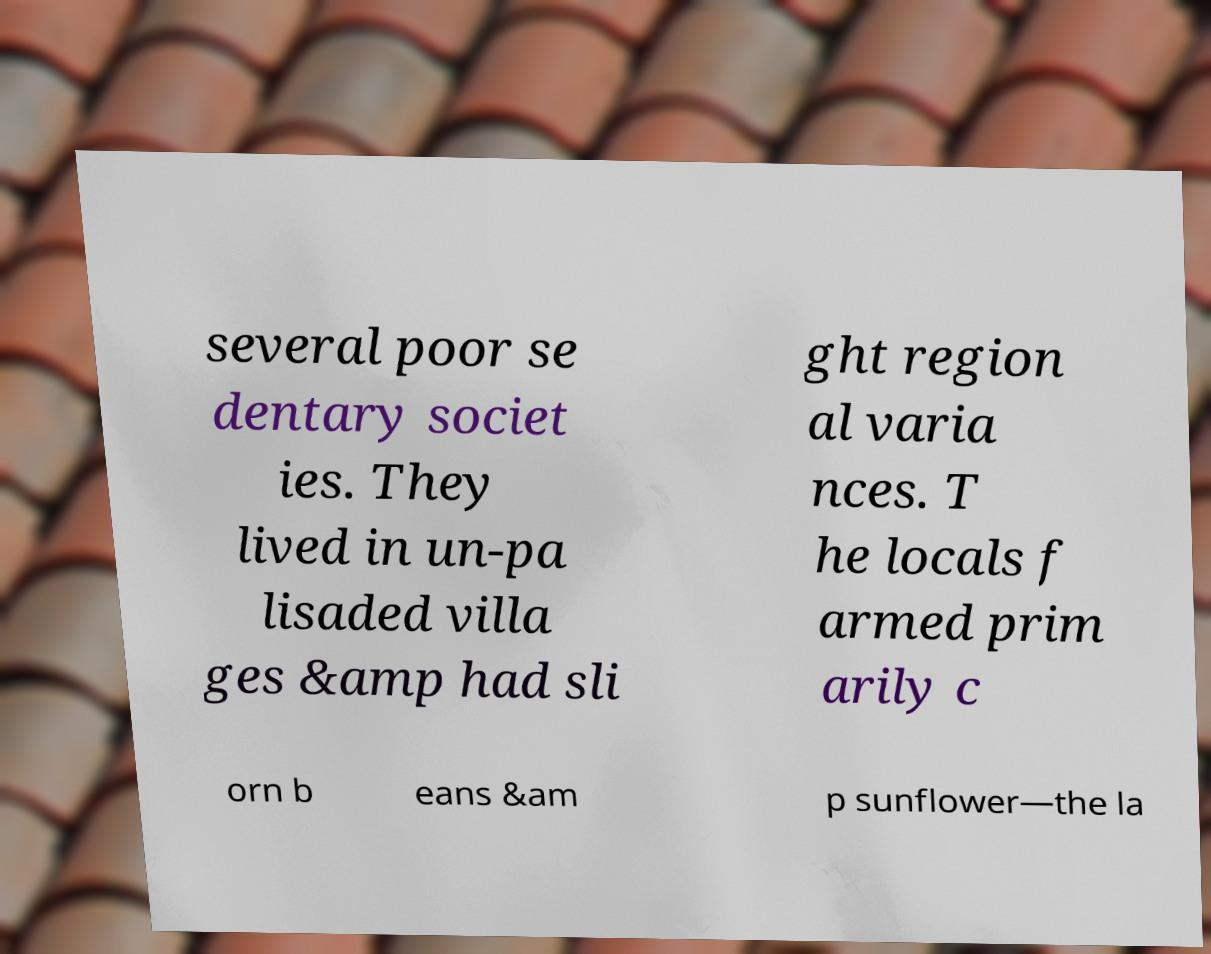Can you read and provide the text displayed in the image?This photo seems to have some interesting text. Can you extract and type it out for me? several poor se dentary societ ies. They lived in un-pa lisaded villa ges &amp had sli ght region al varia nces. T he locals f armed prim arily c orn b eans &am p sunflower—the la 